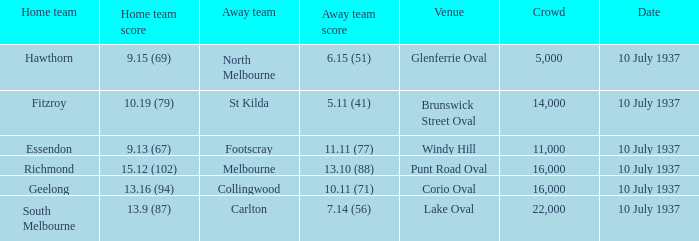What is the minimal gathering with a home team score of 5000.0. Would you be able to parse every entry in this table? {'header': ['Home team', 'Home team score', 'Away team', 'Away team score', 'Venue', 'Crowd', 'Date'], 'rows': [['Hawthorn', '9.15 (69)', 'North Melbourne', '6.15 (51)', 'Glenferrie Oval', '5,000', '10 July 1937'], ['Fitzroy', '10.19 (79)', 'St Kilda', '5.11 (41)', 'Brunswick Street Oval', '14,000', '10 July 1937'], ['Essendon', '9.13 (67)', 'Footscray', '11.11 (77)', 'Windy Hill', '11,000', '10 July 1937'], ['Richmond', '15.12 (102)', 'Melbourne', '13.10 (88)', 'Punt Road Oval', '16,000', '10 July 1937'], ['Geelong', '13.16 (94)', 'Collingwood', '10.11 (71)', 'Corio Oval', '16,000', '10 July 1937'], ['South Melbourne', '13.9 (87)', 'Carlton', '7.14 (56)', 'Lake Oval', '22,000', '10 July 1937']]} 